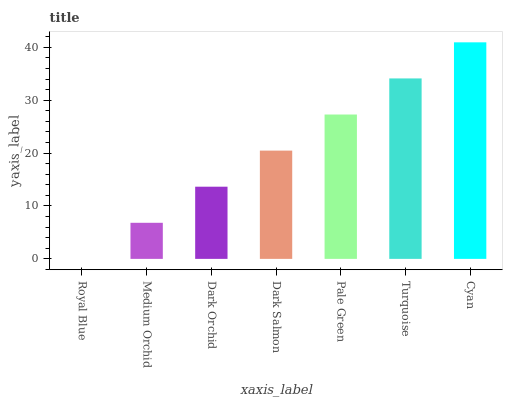Is Royal Blue the minimum?
Answer yes or no. Yes. Is Cyan the maximum?
Answer yes or no. Yes. Is Medium Orchid the minimum?
Answer yes or no. No. Is Medium Orchid the maximum?
Answer yes or no. No. Is Medium Orchid greater than Royal Blue?
Answer yes or no. Yes. Is Royal Blue less than Medium Orchid?
Answer yes or no. Yes. Is Royal Blue greater than Medium Orchid?
Answer yes or no. No. Is Medium Orchid less than Royal Blue?
Answer yes or no. No. Is Dark Salmon the high median?
Answer yes or no. Yes. Is Dark Salmon the low median?
Answer yes or no. Yes. Is Cyan the high median?
Answer yes or no. No. Is Medium Orchid the low median?
Answer yes or no. No. 